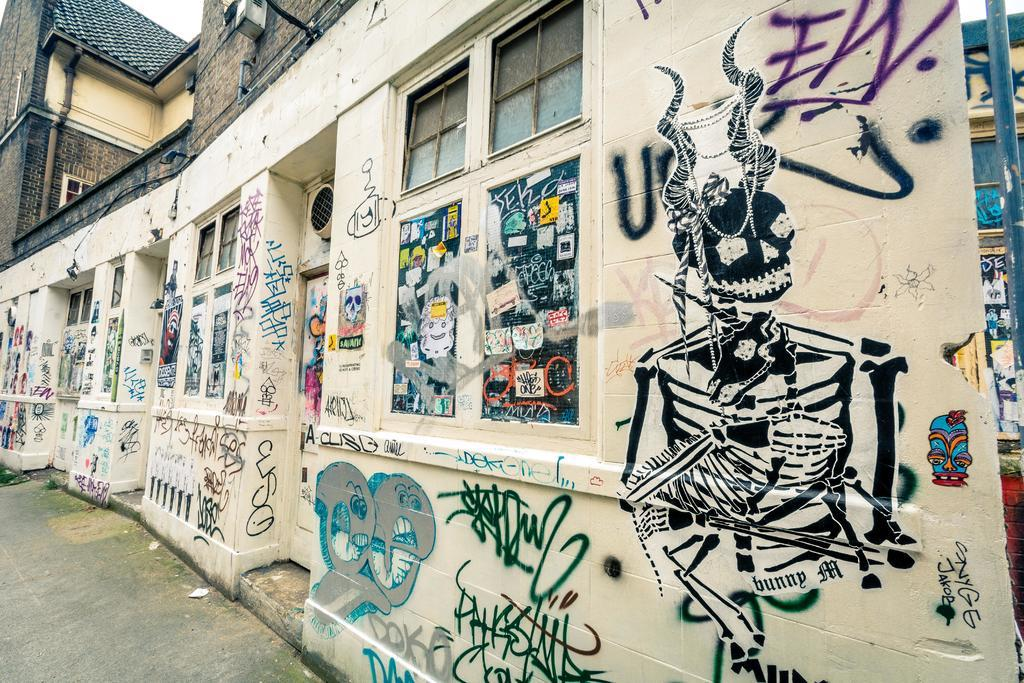What is the main subject of the image? The main subject of the image is a street. What can be seen on the walls in the street? There are paintings on the walls in the street. Is there any structure above the walls with paintings? Yes, there is a building above the walls with paintings. How much blood is visible on the paintings in the image? There is no blood visible on the paintings in the image. What type of stick is being used to create the paintings in the image? There is no indication of a stick or any specific painting tool being used in the image. 